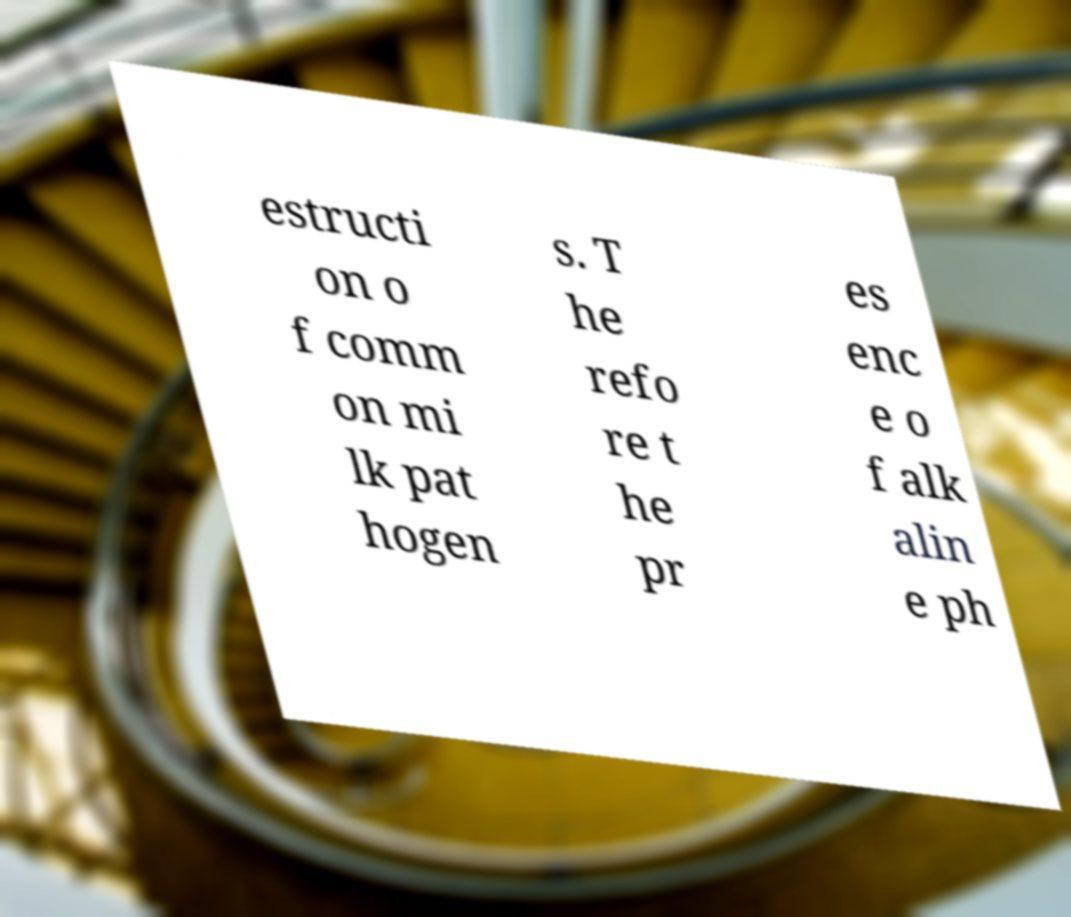What messages or text are displayed in this image? I need them in a readable, typed format. estructi on o f comm on mi lk pat hogen s. T he refo re t he pr es enc e o f alk alin e ph 